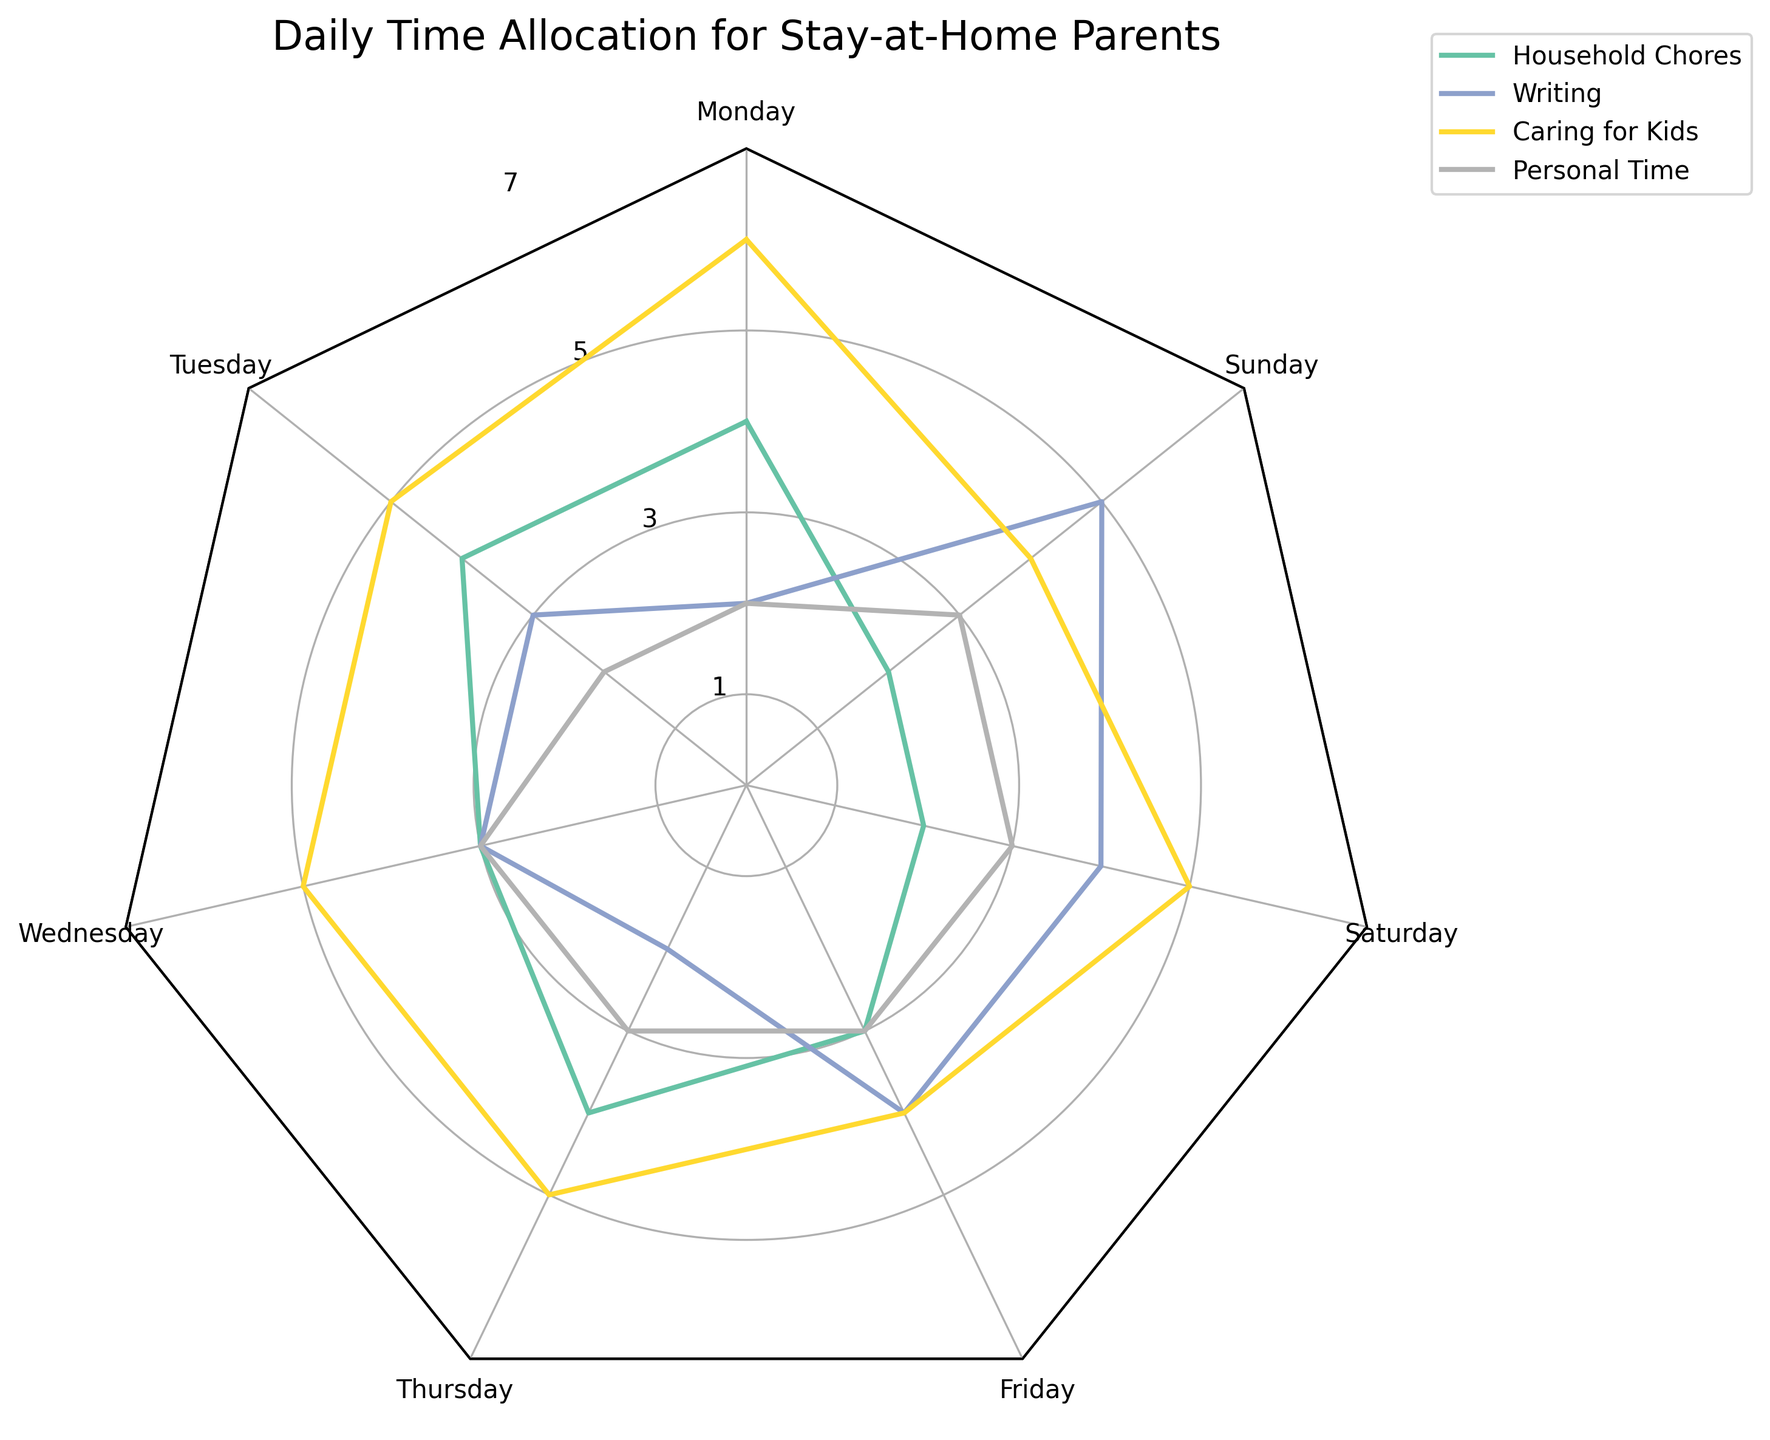What is the title of the chart? The title is prominently displayed at the top of the chart. The exact wording can be read directly.
Answer: Daily Time Allocation for Stay-at-Home Parents Which category has the highest value on Sunday? For Sunday, observe the segments for Household Chores, Writing, Caring for Kids, and Personal Time. The highest point on the radar chart for Sunday is observed in the Writing category.
Answer: Writing How many hours are spent on Household Chores on Wednesday? Locate the spike corresponding to Household Chores and follow it to the value for Wednesday. The value reads 3.
Answer: 3 Which day shows the most balanced allocation across all categories? Balanced allocation means the values are relatively equal across Household Chores, Writing, Caring for Kids, and Personal Time. Look for a day where all segments are about the same length. Wednesday and Thursday show similar allocations, but Wednesday is closer to equal distribution.
Answer: Wednesday On which day is the least amount of time spent on Caring for Kids? Compare the Caring for Kids values across all the days. The minimum value for Caring for Kids, which is 4, is found on Friday and Sunday.
Answer: Sunday and Friday What is the average number of hours spent on Personal Time from Monday to Sunday? Add the Personal Time hours for all days: 2 + 2 + 3 + 3 + 3 + 3 + 3 = 19. Then divide by the total number of days: 19 / 7 ≈ 2.71.
Answer: 2.71 How does Household Chores on Saturday compare to Friday? Look at the Household Chores segments for both days. Saturday has a value of 2 and Friday has a value of 3. Saturday’s value is lower.
Answer: Saturday is lower by 1 hour Which category shows the most variation in hours throughout the week? Measure the spread or range of each category across the days. Household Chores ranges from 2 to 4, Writing from 2 to 5, Caring for Kids from 4 to 6, and Personal Time is stable from 2 to 3. Writing shows the most variation.
Answer: Writing If you had to allocate two more hours on Tuesday without increasing the total, which category could you reduce, and how would you redistribute the hours? Total Tuesday hours: 4 + 3 + 5 + 2 = 14. To stay within 14 hours, reduce Caring for Kids by 2 (5 - 2 = 3) to allocate to another category. Redistribute to Writing (3 + 2 = 5).
Answer: Reduce Caring for Kids to 3 hours, increase Writing to 5 hours 